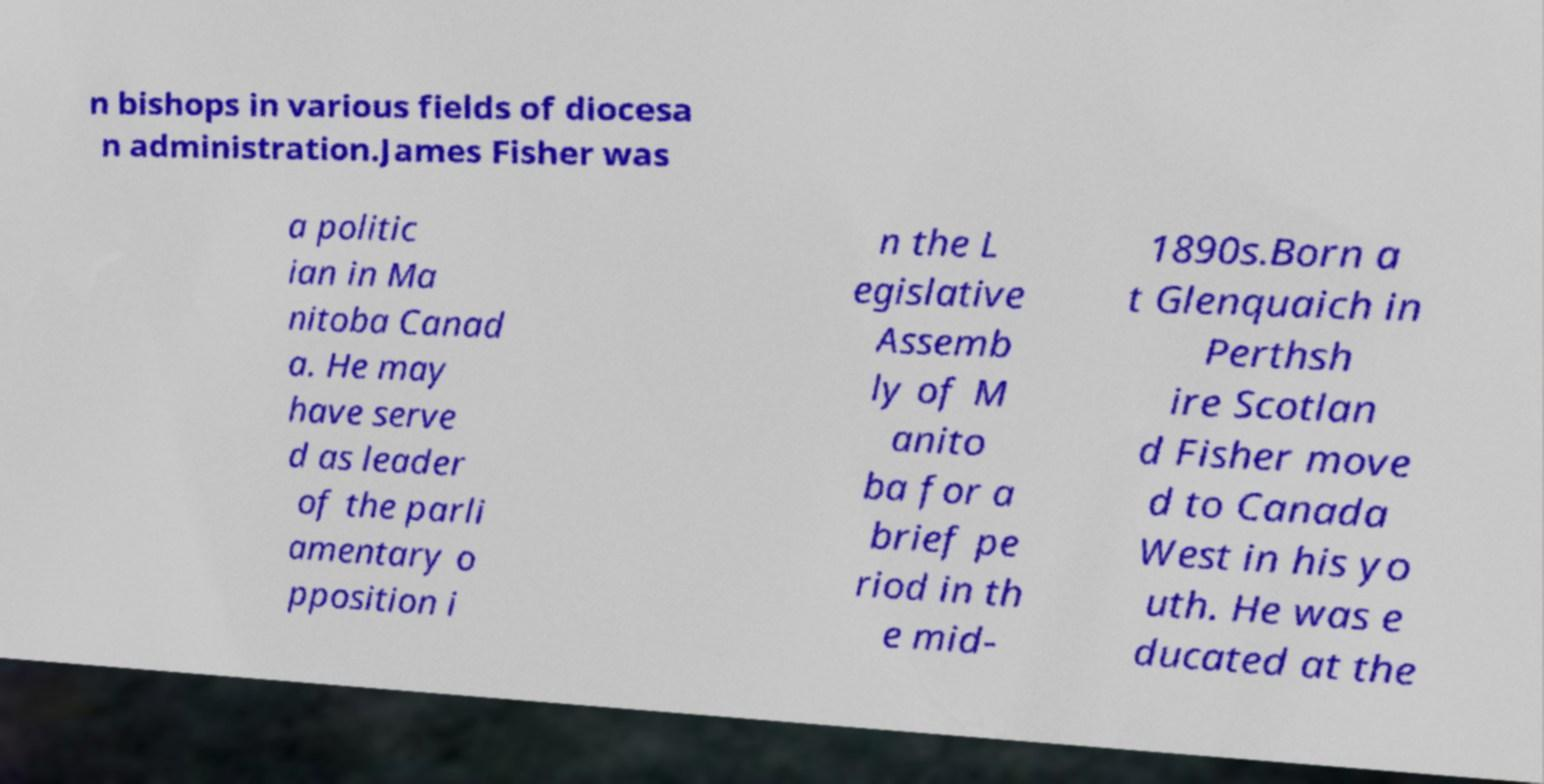For documentation purposes, I need the text within this image transcribed. Could you provide that? n bishops in various fields of diocesa n administration.James Fisher was a politic ian in Ma nitoba Canad a. He may have serve d as leader of the parli amentary o pposition i n the L egislative Assemb ly of M anito ba for a brief pe riod in th e mid- 1890s.Born a t Glenquaich in Perthsh ire Scotlan d Fisher move d to Canada West in his yo uth. He was e ducated at the 